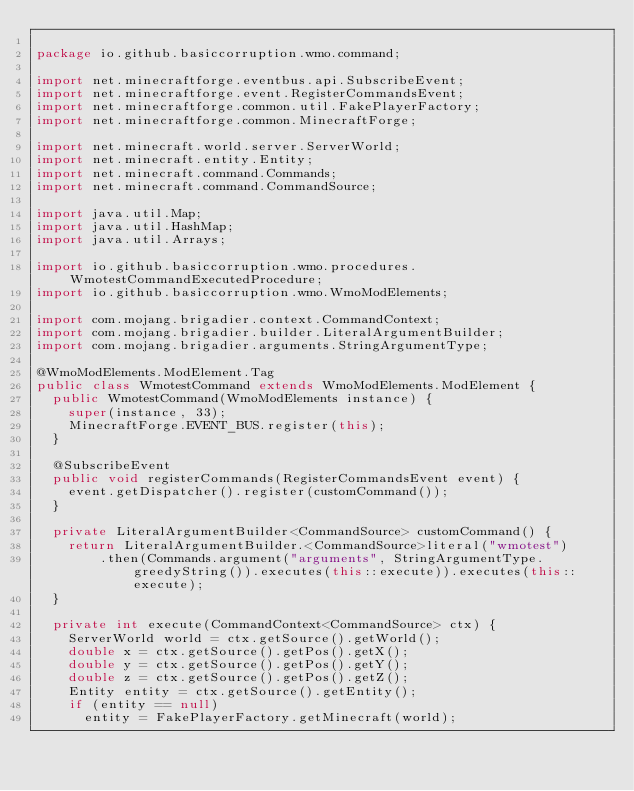<code> <loc_0><loc_0><loc_500><loc_500><_Java_>
package io.github.basiccorruption.wmo.command;

import net.minecraftforge.eventbus.api.SubscribeEvent;
import net.minecraftforge.event.RegisterCommandsEvent;
import net.minecraftforge.common.util.FakePlayerFactory;
import net.minecraftforge.common.MinecraftForge;

import net.minecraft.world.server.ServerWorld;
import net.minecraft.entity.Entity;
import net.minecraft.command.Commands;
import net.minecraft.command.CommandSource;

import java.util.Map;
import java.util.HashMap;
import java.util.Arrays;

import io.github.basiccorruption.wmo.procedures.WmotestCommandExecutedProcedure;
import io.github.basiccorruption.wmo.WmoModElements;

import com.mojang.brigadier.context.CommandContext;
import com.mojang.brigadier.builder.LiteralArgumentBuilder;
import com.mojang.brigadier.arguments.StringArgumentType;

@WmoModElements.ModElement.Tag
public class WmotestCommand extends WmoModElements.ModElement {
	public WmotestCommand(WmoModElements instance) {
		super(instance, 33);
		MinecraftForge.EVENT_BUS.register(this);
	}

	@SubscribeEvent
	public void registerCommands(RegisterCommandsEvent event) {
		event.getDispatcher().register(customCommand());
	}

	private LiteralArgumentBuilder<CommandSource> customCommand() {
		return LiteralArgumentBuilder.<CommandSource>literal("wmotest")
				.then(Commands.argument("arguments", StringArgumentType.greedyString()).executes(this::execute)).executes(this::execute);
	}

	private int execute(CommandContext<CommandSource> ctx) {
		ServerWorld world = ctx.getSource().getWorld();
		double x = ctx.getSource().getPos().getX();
		double y = ctx.getSource().getPos().getY();
		double z = ctx.getSource().getPos().getZ();
		Entity entity = ctx.getSource().getEntity();
		if (entity == null)
			entity = FakePlayerFactory.getMinecraft(world);</code> 